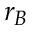Convert formula to latex. <formula><loc_0><loc_0><loc_500><loc_500>r _ { B }</formula> 